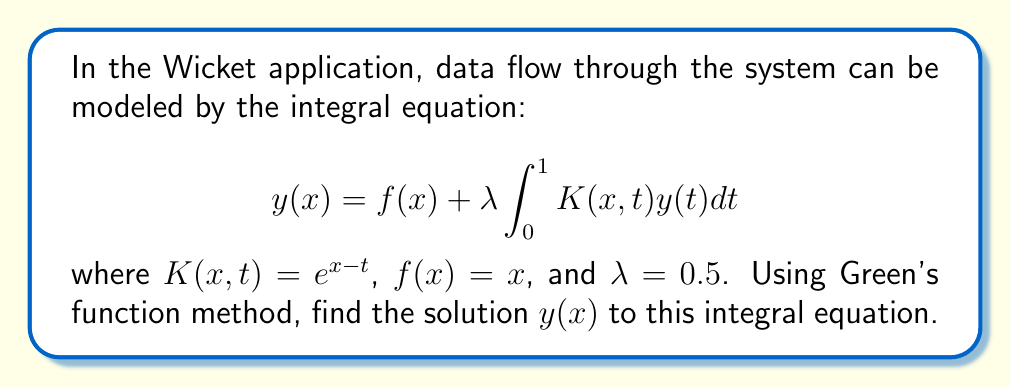Show me your answer to this math problem. To solve this integral equation using Green's function method, we follow these steps:

1) First, we need to find the Green's function $G(x,s)$ that satisfies:

   $$G(x,s) = K(x,s) + \lambda \int_0^1 K(x,t)G(t,s)dt$$

2) For our kernel $K(x,t) = e^{x-t}$, we can assume $G(x,s) = A(s)e^x$. Substituting this into the equation:

   $$A(s)e^x = e^{x-s} + 0.5 \int_0^1 e^{x-t}A(s)e^t dt$$

3) Simplifying:

   $$A(s)e^x = e^{x-s} + 0.5A(s)e^x \int_0^1 dt = e^{x-s} + 0.5A(s)e^x$$

4) Solving for $A(s)$:

   $$A(s) = \frac{e^{-s}}{1-0.5} = 2e^{-s}$$

5) Therefore, the Green's function is:

   $$G(x,s) = 2e^{x-s}$$

6) Now, we can express the solution as:

   $$y(x) = f(x) + \lambda \int_0^1 G(x,s)f(s)ds$$

7) Substituting known values:

   $$y(x) = x + 0.5 \int_0^1 2e^{x-s}s ds$$

8) Evaluating the integral:

   $$y(x) = x + e^x \int_0^1 se^{-s} ds$$

   $$= x + e^x [-se^{-s}|_0^1 + \int_0^1 e^{-s} ds]$$

   $$= x + e^x [-e^{-1} - (-1 + e^{-1})]$$

   $$= x + e^x(1 - 2e^{-1})$$

9) This is our final solution for $y(x)$.
Answer: $y(x) = x + e^x(1 - 2e^{-1})$ 